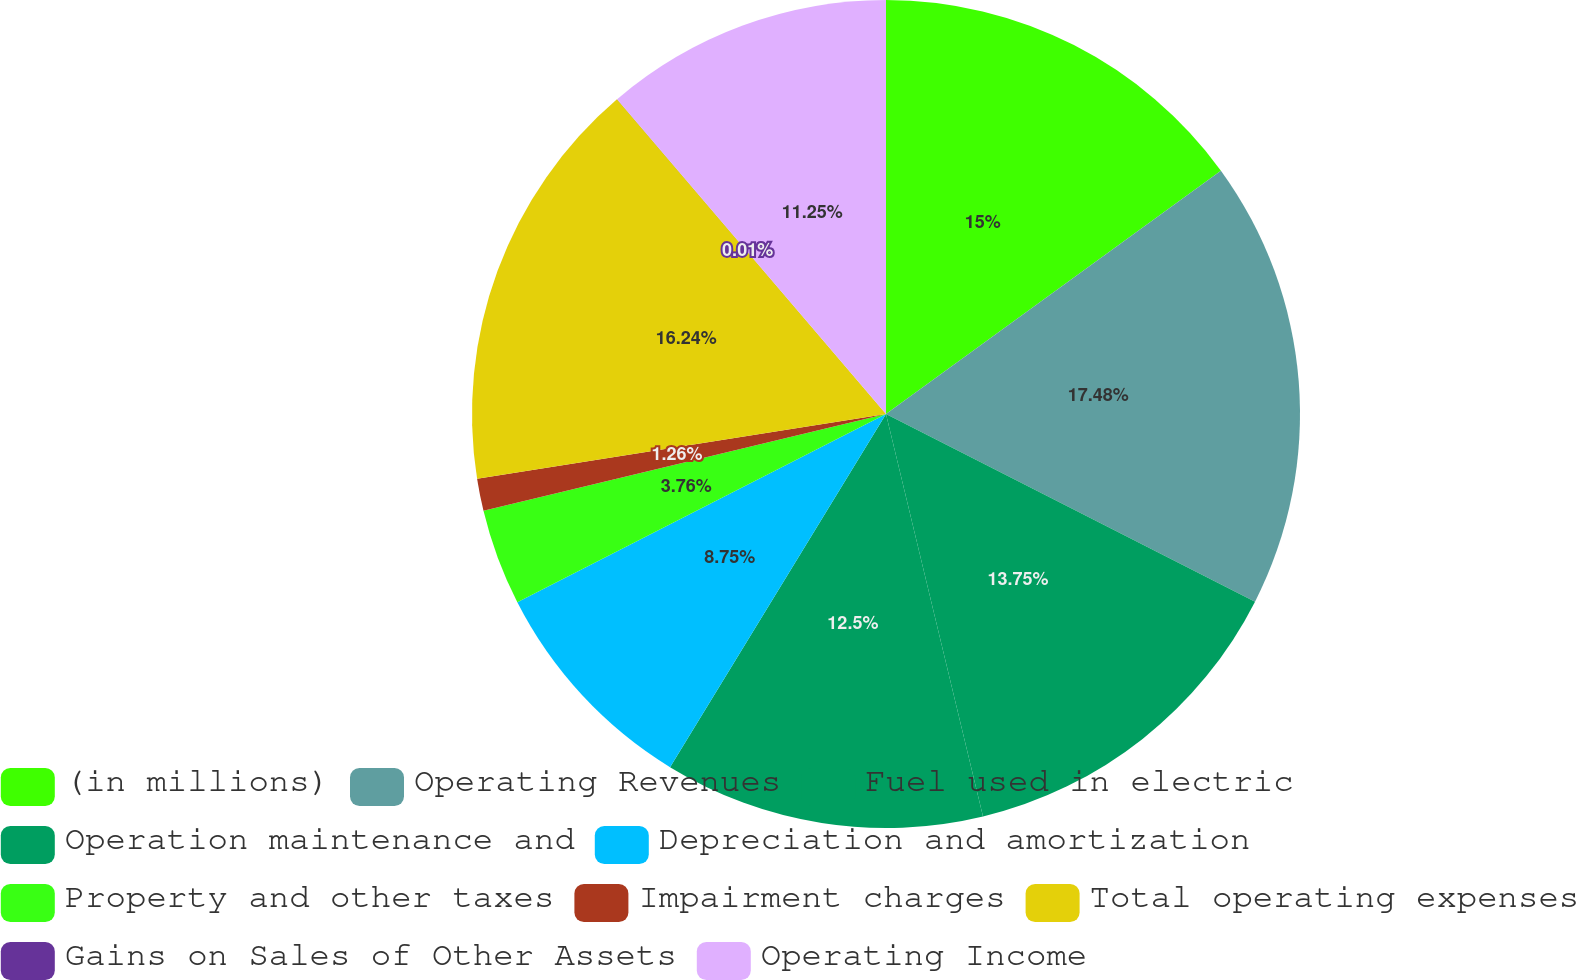Convert chart to OTSL. <chart><loc_0><loc_0><loc_500><loc_500><pie_chart><fcel>(in millions)<fcel>Operating Revenues<fcel>Fuel used in electric<fcel>Operation maintenance and<fcel>Depreciation and amortization<fcel>Property and other taxes<fcel>Impairment charges<fcel>Total operating expenses<fcel>Gains on Sales of Other Assets<fcel>Operating Income<nl><fcel>15.0%<fcel>17.49%<fcel>13.75%<fcel>12.5%<fcel>8.75%<fcel>3.76%<fcel>1.26%<fcel>16.24%<fcel>0.01%<fcel>11.25%<nl></chart> 